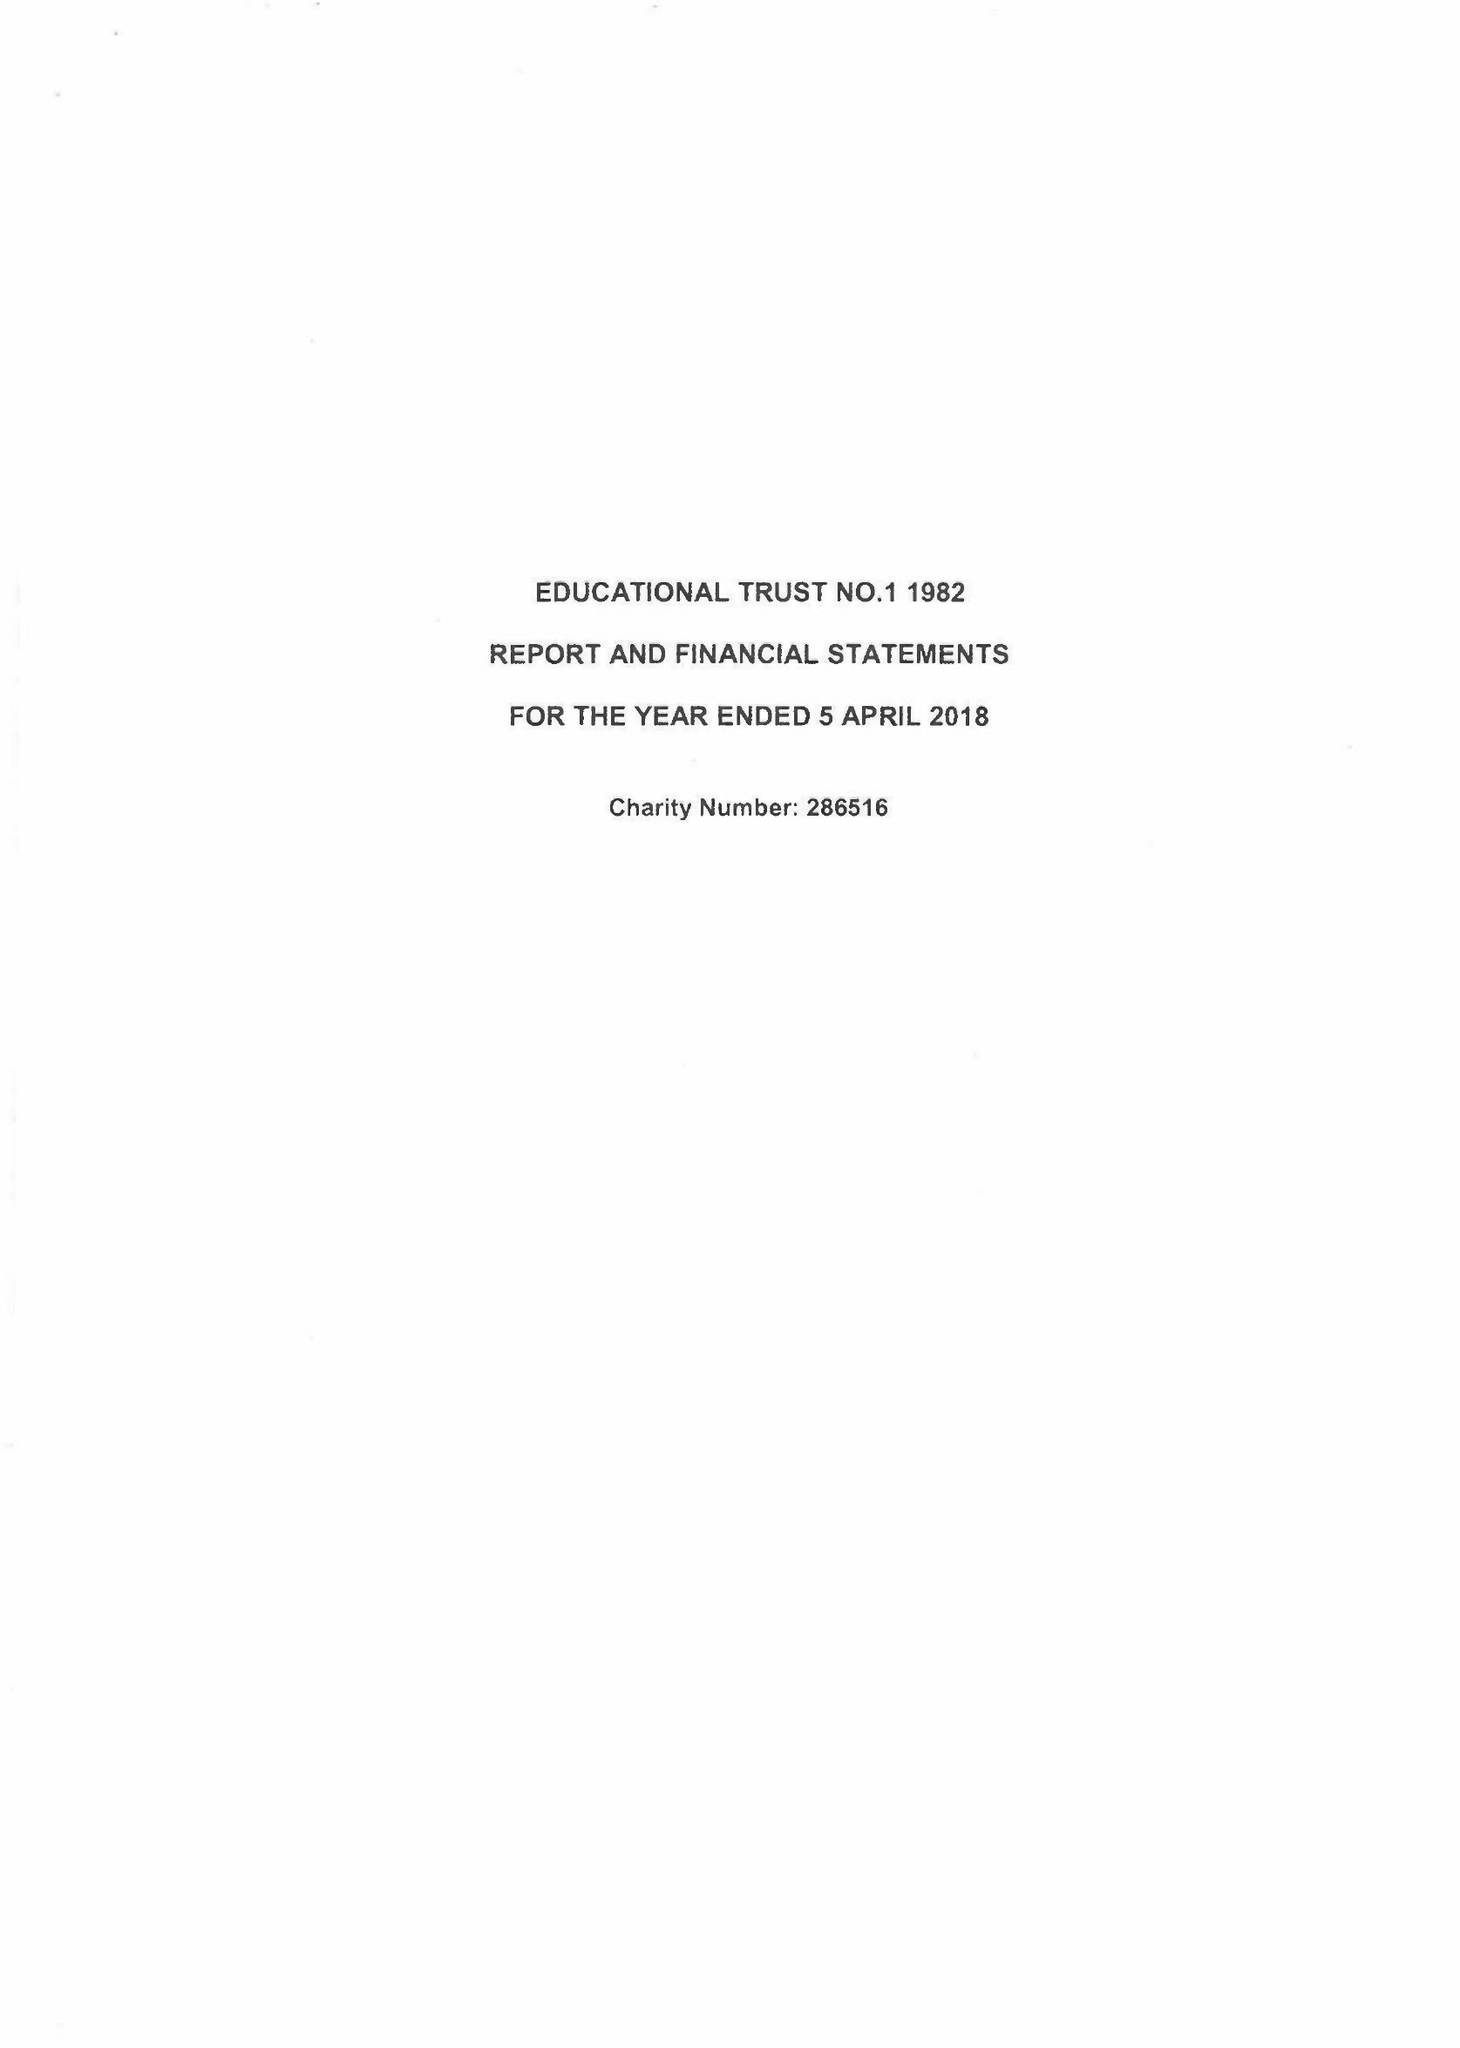What is the value for the address__post_town?
Answer the question using a single word or phrase. FAREHAM 